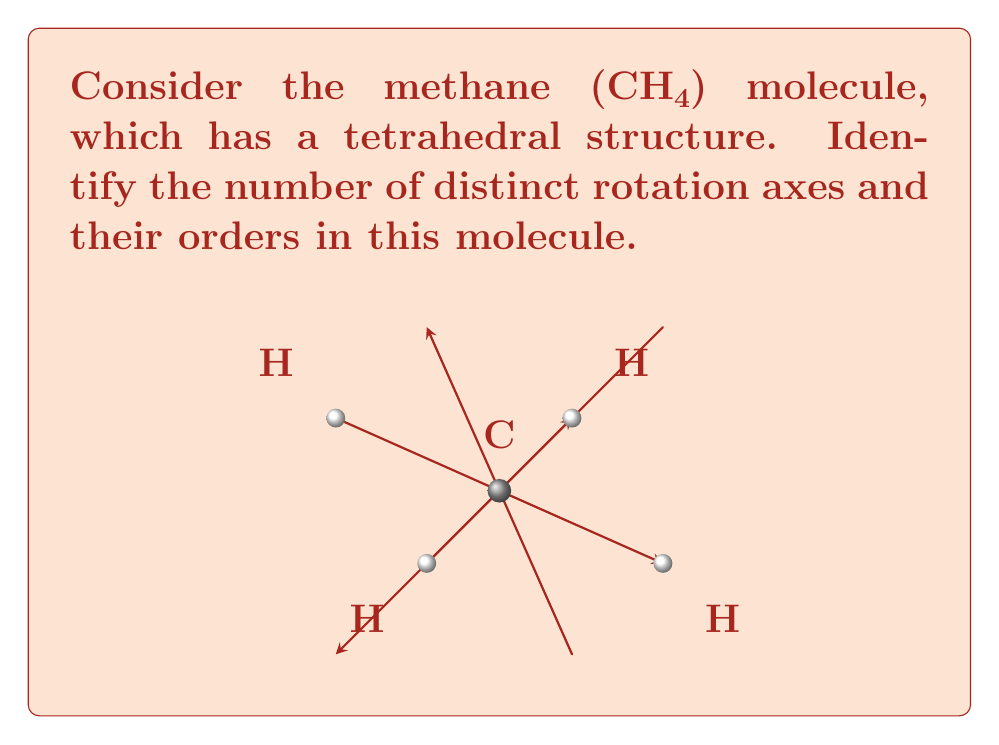Help me with this question. Let's approach this step-by-step:

1) First, we need to understand what rotation axes are in a molecule:
   - A rotation axis is a line around which the molecule can be rotated to produce an identical configuration.
   - The order of a rotation axis is the number of times the molecule must be rotated by $\frac{360°}{n}$ to complete a full rotation.

2) In a tetrahedral structure like methane:

   a) There are four 3-fold (C₃) rotation axes:
      - These pass through each carbon-hydrogen bond.
      - A $120°$ ($\frac{360°}{3}$) rotation about these axes brings the molecule back to an identical configuration.

   b) There are three 2-fold (C₂) rotation axes:
      - These pass through the midpoints of opposite edges of the tetrahedron.
      - A $180°$ ($\frac{360°}{2}$) rotation about these axes brings the molecule back to an identical configuration.

3) To count the distinct rotation axes:
   - 4 C₃ axes (order 3)
   - 3 C₂ axes (order 2)

Therefore, there are 7 distinct rotation axes in total.
Answer: 7 distinct rotation axes: 4 of order 3 and 3 of order 2 